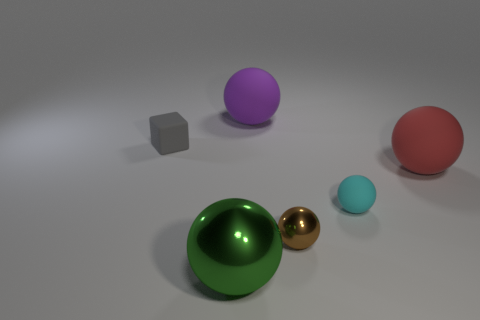Subtract all small metallic spheres. How many spheres are left? 4 Subtract all cyan balls. How many balls are left? 4 Subtract all gray balls. Subtract all green cylinders. How many balls are left? 5 Add 2 small cyan metallic things. How many objects exist? 8 Subtract all cubes. How many objects are left? 5 Subtract 1 green spheres. How many objects are left? 5 Subtract all cyan metal balls. Subtract all tiny brown spheres. How many objects are left? 5 Add 5 tiny matte objects. How many tiny matte objects are left? 7 Add 4 small red matte objects. How many small red matte objects exist? 4 